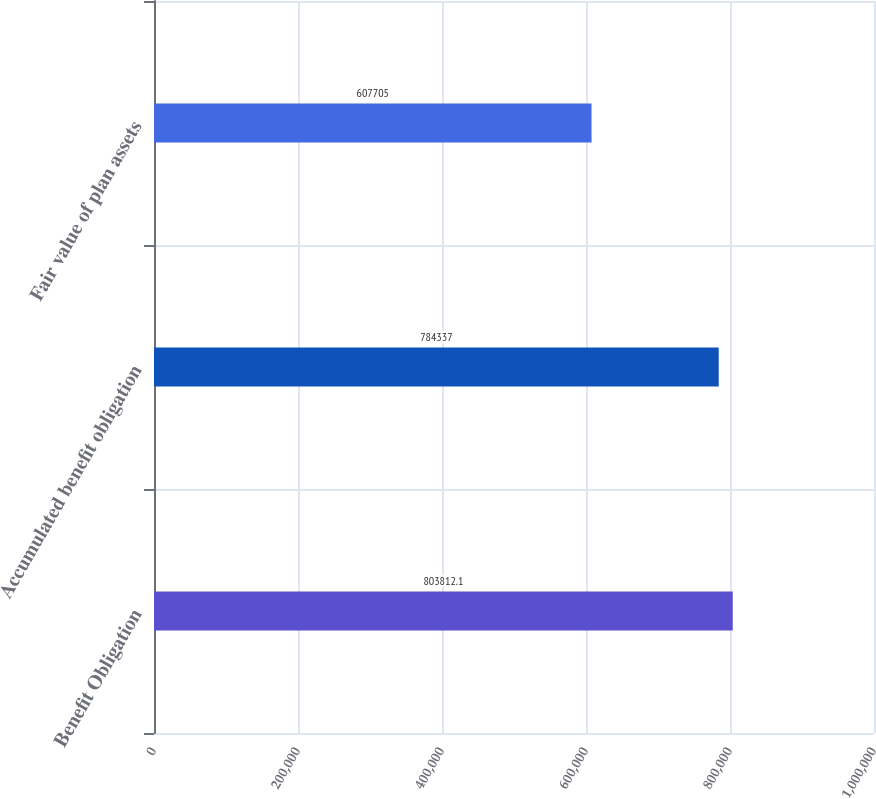Convert chart to OTSL. <chart><loc_0><loc_0><loc_500><loc_500><bar_chart><fcel>Benefit Obligation<fcel>Accumulated benefit obligation<fcel>Fair value of plan assets<nl><fcel>803812<fcel>784337<fcel>607705<nl></chart> 